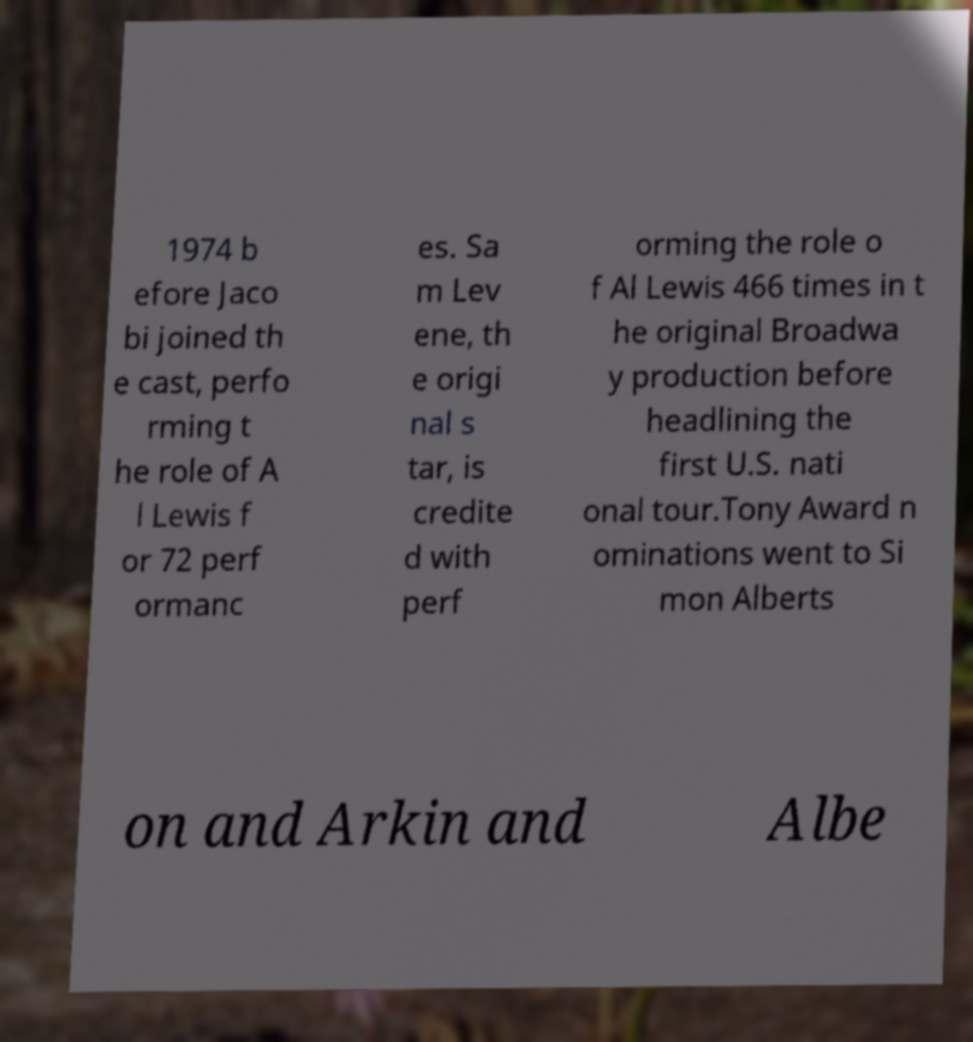There's text embedded in this image that I need extracted. Can you transcribe it verbatim? 1974 b efore Jaco bi joined th e cast, perfo rming t he role of A l Lewis f or 72 perf ormanc es. Sa m Lev ene, th e origi nal s tar, is credite d with perf orming the role o f Al Lewis 466 times in t he original Broadwa y production before headlining the first U.S. nati onal tour.Tony Award n ominations went to Si mon Alberts on and Arkin and Albe 